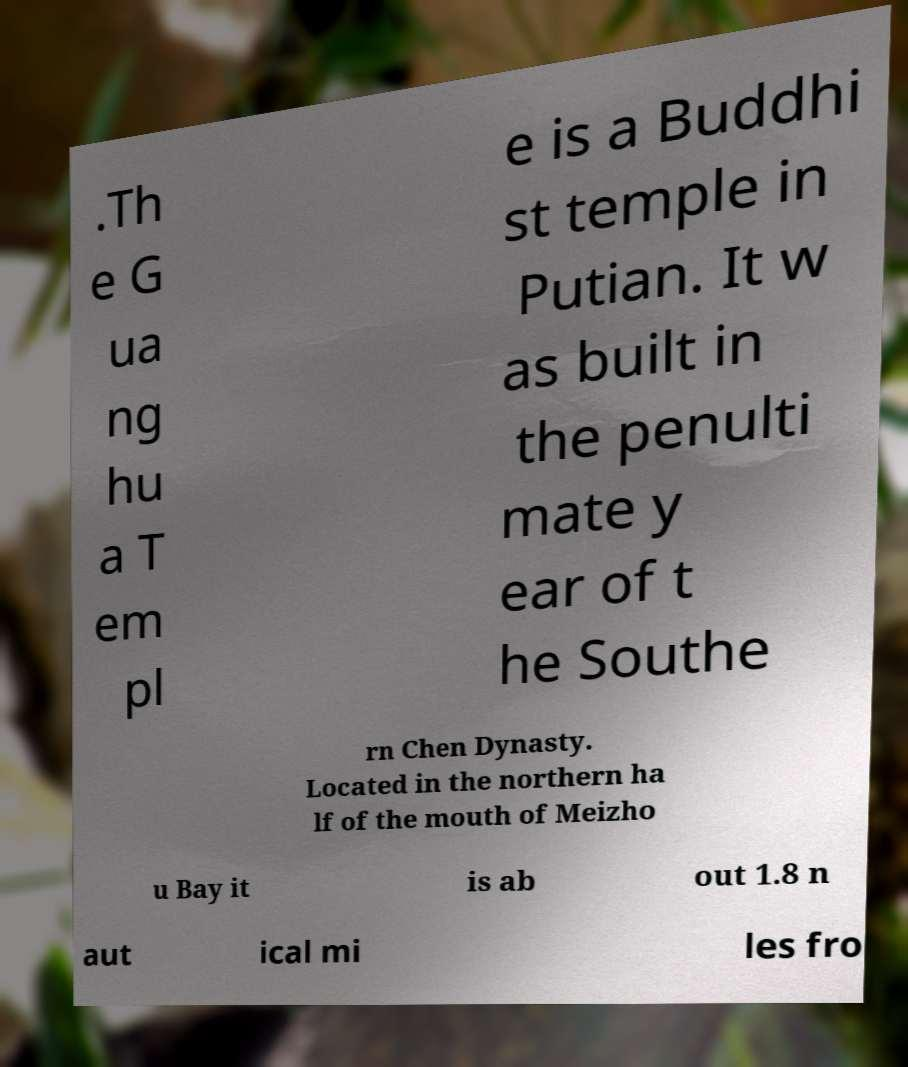Please read and relay the text visible in this image. What does it say? .Th e G ua ng hu a T em pl e is a Buddhi st temple in Putian. It w as built in the penulti mate y ear of t he Southe rn Chen Dynasty. Located in the northern ha lf of the mouth of Meizho u Bay it is ab out 1.8 n aut ical mi les fro 